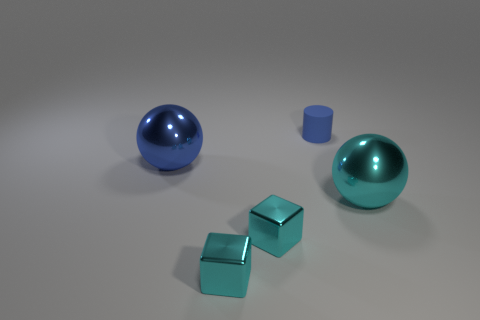Is there any other thing that has the same material as the small cylinder?
Your answer should be very brief. No. There is a object that is the same color as the tiny cylinder; what is its size?
Offer a terse response. Large. Is the color of the small matte thing the same as the ball right of the large blue shiny sphere?
Your response must be concise. No. There is a blue shiny thing; are there any big cyan spheres behind it?
Your response must be concise. No. Do the object that is on the right side of the blue rubber cylinder and the sphere that is left of the blue matte cylinder have the same size?
Give a very brief answer. Yes. Is there another metal ball of the same size as the blue ball?
Your response must be concise. Yes. Is the shape of the thing on the right side of the blue cylinder the same as  the blue metal thing?
Offer a terse response. Yes. What is the ball behind the big cyan thing made of?
Offer a very short reply. Metal. What is the shape of the small object that is behind the ball to the right of the blue rubber cylinder?
Your response must be concise. Cylinder. There is a matte object; is its shape the same as the cyan object right of the small cylinder?
Your answer should be very brief. No. 